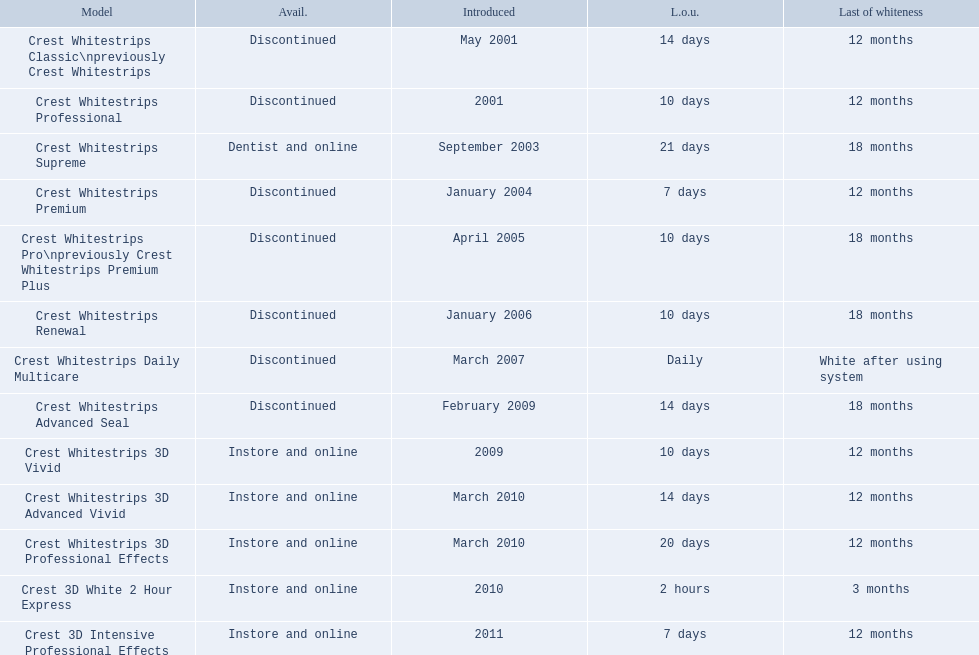What were the models of crest whitestrips? Crest Whitestrips Classic\npreviously Crest Whitestrips, Crest Whitestrips Professional, Crest Whitestrips Supreme, Crest Whitestrips Premium, Crest Whitestrips Pro\npreviously Crest Whitestrips Premium Plus, Crest Whitestrips Renewal, Crest Whitestrips Daily Multicare, Crest Whitestrips Advanced Seal, Crest Whitestrips 3D Vivid, Crest Whitestrips 3D Advanced Vivid, Crest Whitestrips 3D Professional Effects, Crest 3D White 2 Hour Express, Crest 3D Intensive Professional Effects. When were they introduced? May 2001, 2001, September 2003, January 2004, April 2005, January 2006, March 2007, February 2009, 2009, March 2010, March 2010, 2010, 2011. Can you give me this table as a dict? {'header': ['Model', 'Avail.', 'Introduced', 'L.o.u.', 'Last of whiteness'], 'rows': [['Crest Whitestrips Classic\\npreviously Crest Whitestrips', 'Discontinued', 'May 2001', '14 days', '12 months'], ['Crest Whitestrips Professional', 'Discontinued', '2001', '10 days', '12 months'], ['Crest Whitestrips Supreme', 'Dentist and online', 'September 2003', '21 days', '18 months'], ['Crest Whitestrips Premium', 'Discontinued', 'January 2004', '7 days', '12 months'], ['Crest Whitestrips Pro\\npreviously Crest Whitestrips Premium Plus', 'Discontinued', 'April 2005', '10 days', '18 months'], ['Crest Whitestrips Renewal', 'Discontinued', 'January 2006', '10 days', '18 months'], ['Crest Whitestrips Daily Multicare', 'Discontinued', 'March 2007', 'Daily', 'White after using system'], ['Crest Whitestrips Advanced Seal', 'Discontinued', 'February 2009', '14 days', '18 months'], ['Crest Whitestrips 3D Vivid', 'Instore and online', '2009', '10 days', '12 months'], ['Crest Whitestrips 3D Advanced Vivid', 'Instore and online', 'March 2010', '14 days', '12 months'], ['Crest Whitestrips 3D Professional Effects', 'Instore and online', 'March 2010', '20 days', '12 months'], ['Crest 3D White 2 Hour Express', 'Instore and online', '2010', '2 hours', '3 months'], ['Crest 3D Intensive Professional Effects', 'Instore and online', '2011', '7 days', '12 months']]} And what is their availability? Discontinued, Discontinued, Dentist and online, Discontinued, Discontinued, Discontinued, Discontinued, Discontinued, Instore and online, Instore and online, Instore and online, Instore and online, Instore and online. Along crest whitestrips 3d vivid, which discontinued model was released in 2009? Crest Whitestrips Advanced Seal. 